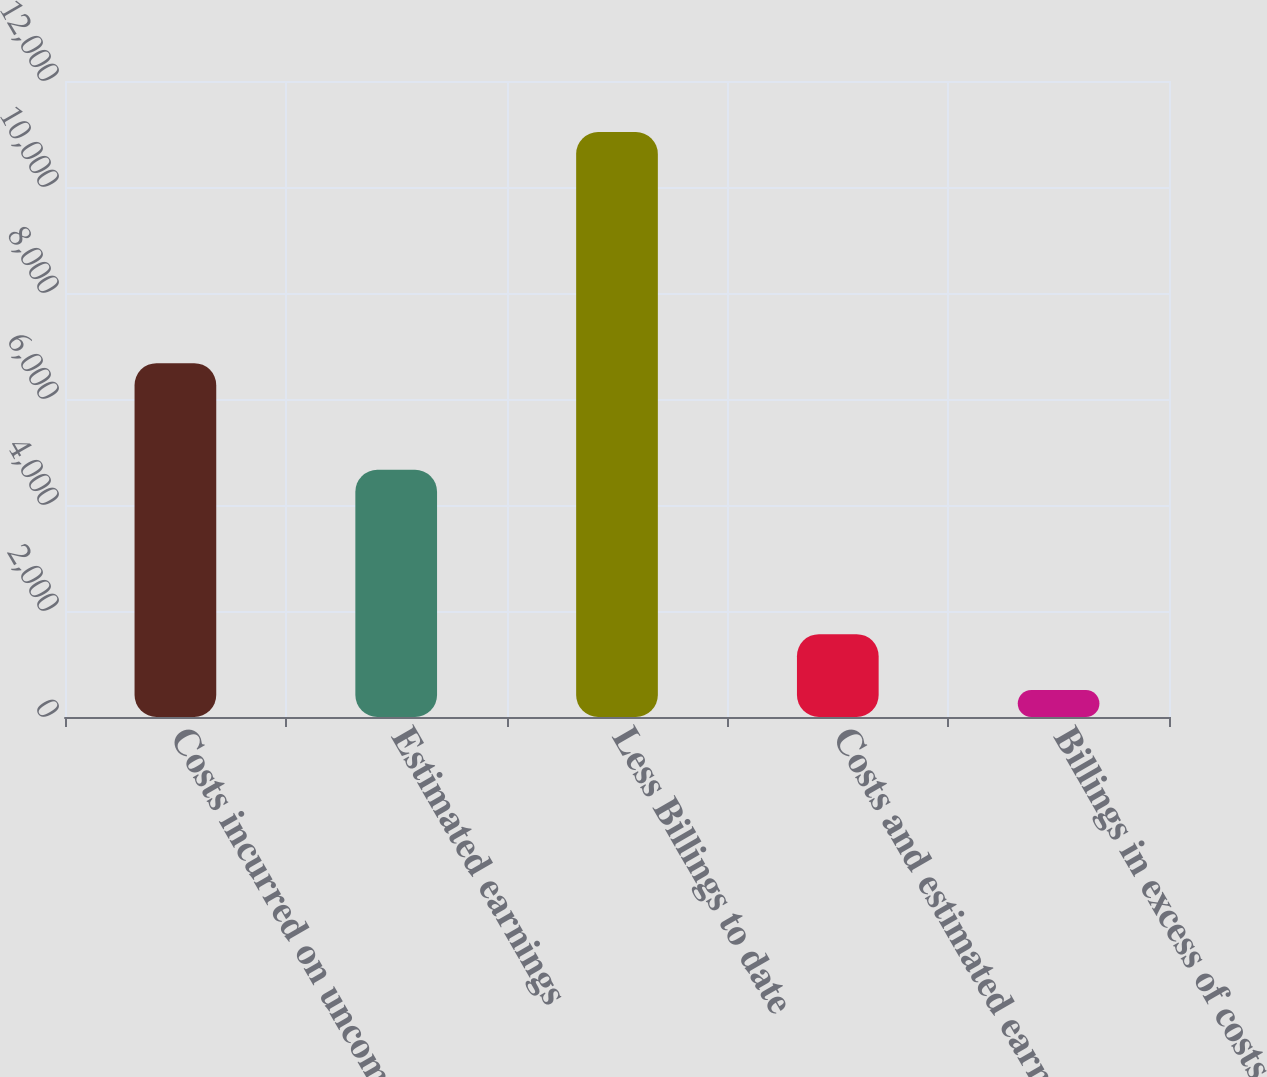Convert chart to OTSL. <chart><loc_0><loc_0><loc_500><loc_500><bar_chart><fcel>Costs incurred on uncompleted<fcel>Estimated earnings<fcel>Less Billings to date<fcel>Costs and estimated earnings<fcel>Billings in excess of costs<nl><fcel>6676<fcel>4665<fcel>11037<fcel>1563.6<fcel>511<nl></chart> 